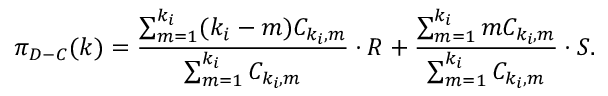<formula> <loc_0><loc_0><loc_500><loc_500>\pi _ { D - C } ( k ) = \frac { \sum _ { m = 1 } ^ { k _ { i } } ( k _ { i } - m ) C _ { k _ { i } , m } } { \sum _ { m = 1 } ^ { k _ { i } } C _ { k _ { i } , m } } \cdot R + \frac { \sum _ { m = 1 } ^ { k _ { i } } m C _ { k _ { i } , m } } { \sum _ { m = 1 } ^ { k _ { i } } C _ { k _ { i } , m } } \cdot S .</formula> 